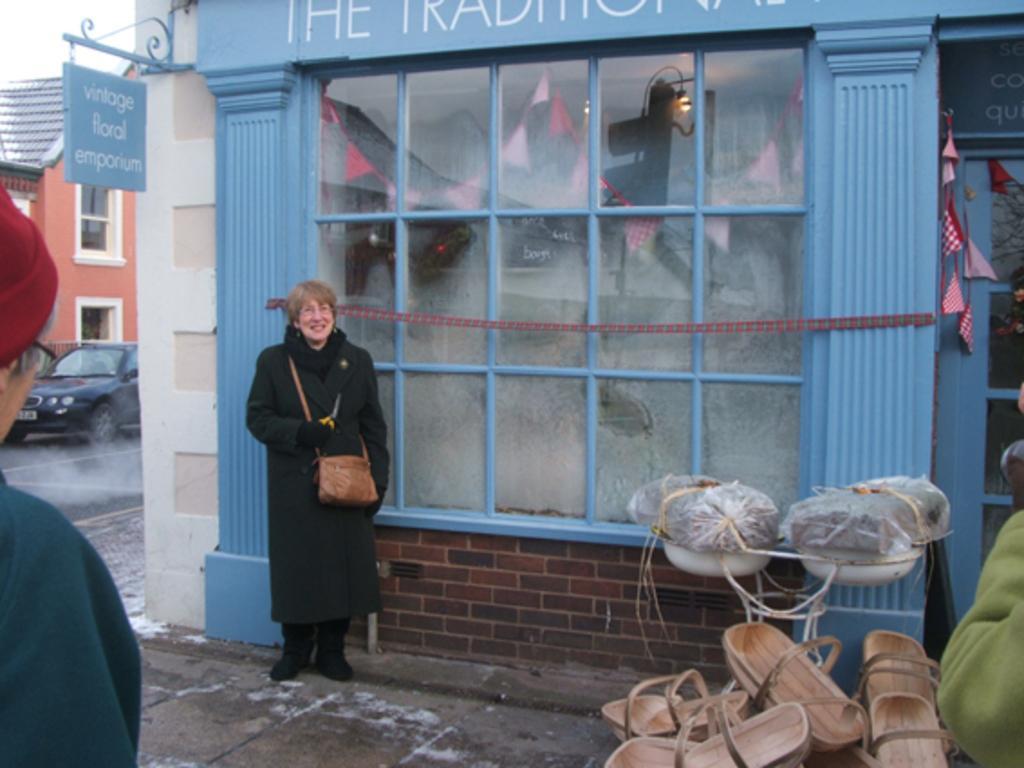Please provide a concise description of this image. This image is taken outdoors. At the bottom of the image there is a floor. There are a few wooden objects. There are two people. In the background there are two buildings. There are two boards with text on them. A car is parked on the road. In the middle of the image a woman is standing on the floor and she is holding a handbag in her hand. She is with a smiling face. 